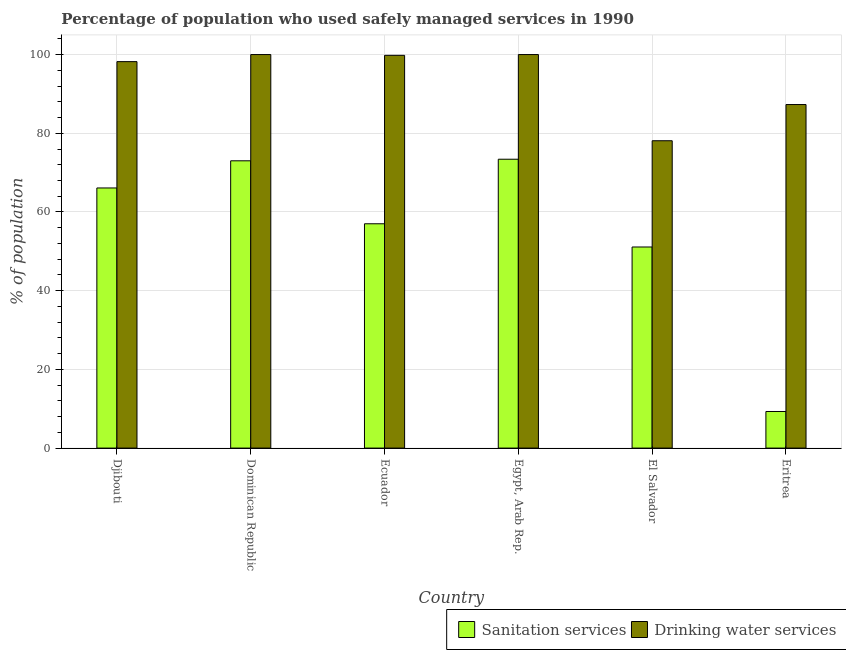How many different coloured bars are there?
Offer a terse response. 2. Are the number of bars per tick equal to the number of legend labels?
Your response must be concise. Yes. How many bars are there on the 3rd tick from the right?
Give a very brief answer. 2. What is the label of the 3rd group of bars from the left?
Your answer should be very brief. Ecuador. In how many cases, is the number of bars for a given country not equal to the number of legend labels?
Provide a succinct answer. 0. What is the percentage of population who used drinking water services in Ecuador?
Your answer should be very brief. 99.8. Across all countries, what is the maximum percentage of population who used sanitation services?
Provide a short and direct response. 73.4. Across all countries, what is the minimum percentage of population who used drinking water services?
Provide a succinct answer. 78.1. In which country was the percentage of population who used sanitation services maximum?
Your answer should be compact. Egypt, Arab Rep. In which country was the percentage of population who used drinking water services minimum?
Ensure brevity in your answer.  El Salvador. What is the total percentage of population who used drinking water services in the graph?
Give a very brief answer. 563.4. What is the difference between the percentage of population who used drinking water services in Djibouti and that in Eritrea?
Your response must be concise. 10.9. What is the difference between the percentage of population who used drinking water services in Ecuador and the percentage of population who used sanitation services in Egypt, Arab Rep.?
Ensure brevity in your answer.  26.4. What is the average percentage of population who used drinking water services per country?
Your answer should be very brief. 93.9. What is the difference between the percentage of population who used sanitation services and percentage of population who used drinking water services in Dominican Republic?
Make the answer very short. -27. What is the ratio of the percentage of population who used sanitation services in Dominican Republic to that in El Salvador?
Provide a succinct answer. 1.43. Is the percentage of population who used sanitation services in Ecuador less than that in Eritrea?
Provide a short and direct response. No. Is the difference between the percentage of population who used sanitation services in Ecuador and Egypt, Arab Rep. greater than the difference between the percentage of population who used drinking water services in Ecuador and Egypt, Arab Rep.?
Make the answer very short. No. What is the difference between the highest and the second highest percentage of population who used sanitation services?
Your answer should be compact. 0.4. What is the difference between the highest and the lowest percentage of population who used drinking water services?
Keep it short and to the point. 21.9. Is the sum of the percentage of population who used sanitation services in Dominican Republic and Eritrea greater than the maximum percentage of population who used drinking water services across all countries?
Keep it short and to the point. No. What does the 1st bar from the left in Djibouti represents?
Your answer should be very brief. Sanitation services. What does the 2nd bar from the right in Egypt, Arab Rep. represents?
Ensure brevity in your answer.  Sanitation services. Are all the bars in the graph horizontal?
Your answer should be compact. No. How many countries are there in the graph?
Your answer should be compact. 6. Does the graph contain any zero values?
Provide a short and direct response. No. How many legend labels are there?
Provide a short and direct response. 2. How are the legend labels stacked?
Keep it short and to the point. Horizontal. What is the title of the graph?
Provide a short and direct response. Percentage of population who used safely managed services in 1990. What is the label or title of the X-axis?
Offer a very short reply. Country. What is the label or title of the Y-axis?
Make the answer very short. % of population. What is the % of population in Sanitation services in Djibouti?
Your answer should be very brief. 66.1. What is the % of population in Drinking water services in Djibouti?
Offer a very short reply. 98.2. What is the % of population of Sanitation services in Dominican Republic?
Keep it short and to the point. 73. What is the % of population of Drinking water services in Dominican Republic?
Provide a succinct answer. 100. What is the % of population of Drinking water services in Ecuador?
Provide a short and direct response. 99.8. What is the % of population in Sanitation services in Egypt, Arab Rep.?
Ensure brevity in your answer.  73.4. What is the % of population in Drinking water services in Egypt, Arab Rep.?
Offer a terse response. 100. What is the % of population in Sanitation services in El Salvador?
Offer a very short reply. 51.1. What is the % of population of Drinking water services in El Salvador?
Your answer should be compact. 78.1. What is the % of population of Sanitation services in Eritrea?
Your answer should be very brief. 9.3. What is the % of population in Drinking water services in Eritrea?
Give a very brief answer. 87.3. Across all countries, what is the maximum % of population of Sanitation services?
Ensure brevity in your answer.  73.4. Across all countries, what is the minimum % of population in Sanitation services?
Your response must be concise. 9.3. Across all countries, what is the minimum % of population of Drinking water services?
Provide a short and direct response. 78.1. What is the total % of population in Sanitation services in the graph?
Your answer should be very brief. 329.9. What is the total % of population of Drinking water services in the graph?
Provide a short and direct response. 563.4. What is the difference between the % of population in Sanitation services in Djibouti and that in Dominican Republic?
Ensure brevity in your answer.  -6.9. What is the difference between the % of population in Sanitation services in Djibouti and that in Ecuador?
Give a very brief answer. 9.1. What is the difference between the % of population of Sanitation services in Djibouti and that in Egypt, Arab Rep.?
Your response must be concise. -7.3. What is the difference between the % of population in Sanitation services in Djibouti and that in El Salvador?
Give a very brief answer. 15. What is the difference between the % of population of Drinking water services in Djibouti and that in El Salvador?
Offer a very short reply. 20.1. What is the difference between the % of population in Sanitation services in Djibouti and that in Eritrea?
Keep it short and to the point. 56.8. What is the difference between the % of population of Drinking water services in Dominican Republic and that in Ecuador?
Your answer should be compact. 0.2. What is the difference between the % of population of Drinking water services in Dominican Republic and that in Egypt, Arab Rep.?
Offer a terse response. 0. What is the difference between the % of population of Sanitation services in Dominican Republic and that in El Salvador?
Your answer should be very brief. 21.9. What is the difference between the % of population in Drinking water services in Dominican Republic and that in El Salvador?
Ensure brevity in your answer.  21.9. What is the difference between the % of population in Sanitation services in Dominican Republic and that in Eritrea?
Offer a terse response. 63.7. What is the difference between the % of population in Sanitation services in Ecuador and that in Egypt, Arab Rep.?
Keep it short and to the point. -16.4. What is the difference between the % of population of Sanitation services in Ecuador and that in El Salvador?
Give a very brief answer. 5.9. What is the difference between the % of population of Drinking water services in Ecuador and that in El Salvador?
Give a very brief answer. 21.7. What is the difference between the % of population in Sanitation services in Ecuador and that in Eritrea?
Your answer should be compact. 47.7. What is the difference between the % of population in Sanitation services in Egypt, Arab Rep. and that in El Salvador?
Keep it short and to the point. 22.3. What is the difference between the % of population of Drinking water services in Egypt, Arab Rep. and that in El Salvador?
Offer a terse response. 21.9. What is the difference between the % of population of Sanitation services in Egypt, Arab Rep. and that in Eritrea?
Ensure brevity in your answer.  64.1. What is the difference between the % of population of Drinking water services in Egypt, Arab Rep. and that in Eritrea?
Make the answer very short. 12.7. What is the difference between the % of population of Sanitation services in El Salvador and that in Eritrea?
Your answer should be very brief. 41.8. What is the difference between the % of population of Sanitation services in Djibouti and the % of population of Drinking water services in Dominican Republic?
Your answer should be very brief. -33.9. What is the difference between the % of population of Sanitation services in Djibouti and the % of population of Drinking water services in Ecuador?
Offer a very short reply. -33.7. What is the difference between the % of population in Sanitation services in Djibouti and the % of population in Drinking water services in Egypt, Arab Rep.?
Give a very brief answer. -33.9. What is the difference between the % of population in Sanitation services in Djibouti and the % of population in Drinking water services in Eritrea?
Your answer should be compact. -21.2. What is the difference between the % of population in Sanitation services in Dominican Republic and the % of population in Drinking water services in Ecuador?
Your answer should be compact. -26.8. What is the difference between the % of population in Sanitation services in Dominican Republic and the % of population in Drinking water services in Eritrea?
Make the answer very short. -14.3. What is the difference between the % of population of Sanitation services in Ecuador and the % of population of Drinking water services in Egypt, Arab Rep.?
Provide a short and direct response. -43. What is the difference between the % of population of Sanitation services in Ecuador and the % of population of Drinking water services in El Salvador?
Offer a very short reply. -21.1. What is the difference between the % of population in Sanitation services in Ecuador and the % of population in Drinking water services in Eritrea?
Offer a very short reply. -30.3. What is the difference between the % of population of Sanitation services in Egypt, Arab Rep. and the % of population of Drinking water services in El Salvador?
Make the answer very short. -4.7. What is the difference between the % of population in Sanitation services in Egypt, Arab Rep. and the % of population in Drinking water services in Eritrea?
Your answer should be very brief. -13.9. What is the difference between the % of population in Sanitation services in El Salvador and the % of population in Drinking water services in Eritrea?
Offer a terse response. -36.2. What is the average % of population of Sanitation services per country?
Your response must be concise. 54.98. What is the average % of population of Drinking water services per country?
Offer a very short reply. 93.9. What is the difference between the % of population in Sanitation services and % of population in Drinking water services in Djibouti?
Offer a terse response. -32.1. What is the difference between the % of population in Sanitation services and % of population in Drinking water services in Dominican Republic?
Ensure brevity in your answer.  -27. What is the difference between the % of population of Sanitation services and % of population of Drinking water services in Ecuador?
Your answer should be compact. -42.8. What is the difference between the % of population of Sanitation services and % of population of Drinking water services in Egypt, Arab Rep.?
Provide a succinct answer. -26.6. What is the difference between the % of population in Sanitation services and % of population in Drinking water services in El Salvador?
Make the answer very short. -27. What is the difference between the % of population in Sanitation services and % of population in Drinking water services in Eritrea?
Make the answer very short. -78. What is the ratio of the % of population of Sanitation services in Djibouti to that in Dominican Republic?
Your answer should be very brief. 0.91. What is the ratio of the % of population of Sanitation services in Djibouti to that in Ecuador?
Ensure brevity in your answer.  1.16. What is the ratio of the % of population of Drinking water services in Djibouti to that in Ecuador?
Your answer should be very brief. 0.98. What is the ratio of the % of population in Sanitation services in Djibouti to that in Egypt, Arab Rep.?
Your answer should be compact. 0.9. What is the ratio of the % of population in Drinking water services in Djibouti to that in Egypt, Arab Rep.?
Ensure brevity in your answer.  0.98. What is the ratio of the % of population of Sanitation services in Djibouti to that in El Salvador?
Make the answer very short. 1.29. What is the ratio of the % of population in Drinking water services in Djibouti to that in El Salvador?
Provide a short and direct response. 1.26. What is the ratio of the % of population in Sanitation services in Djibouti to that in Eritrea?
Your response must be concise. 7.11. What is the ratio of the % of population in Drinking water services in Djibouti to that in Eritrea?
Your answer should be compact. 1.12. What is the ratio of the % of population in Sanitation services in Dominican Republic to that in Ecuador?
Provide a succinct answer. 1.28. What is the ratio of the % of population in Sanitation services in Dominican Republic to that in El Salvador?
Your answer should be very brief. 1.43. What is the ratio of the % of population in Drinking water services in Dominican Republic to that in El Salvador?
Provide a succinct answer. 1.28. What is the ratio of the % of population of Sanitation services in Dominican Republic to that in Eritrea?
Ensure brevity in your answer.  7.85. What is the ratio of the % of population of Drinking water services in Dominican Republic to that in Eritrea?
Make the answer very short. 1.15. What is the ratio of the % of population in Sanitation services in Ecuador to that in Egypt, Arab Rep.?
Offer a terse response. 0.78. What is the ratio of the % of population in Drinking water services in Ecuador to that in Egypt, Arab Rep.?
Offer a terse response. 1. What is the ratio of the % of population of Sanitation services in Ecuador to that in El Salvador?
Provide a succinct answer. 1.12. What is the ratio of the % of population in Drinking water services in Ecuador to that in El Salvador?
Your answer should be very brief. 1.28. What is the ratio of the % of population of Sanitation services in Ecuador to that in Eritrea?
Give a very brief answer. 6.13. What is the ratio of the % of population of Drinking water services in Ecuador to that in Eritrea?
Provide a succinct answer. 1.14. What is the ratio of the % of population of Sanitation services in Egypt, Arab Rep. to that in El Salvador?
Make the answer very short. 1.44. What is the ratio of the % of population in Drinking water services in Egypt, Arab Rep. to that in El Salvador?
Give a very brief answer. 1.28. What is the ratio of the % of population in Sanitation services in Egypt, Arab Rep. to that in Eritrea?
Give a very brief answer. 7.89. What is the ratio of the % of population of Drinking water services in Egypt, Arab Rep. to that in Eritrea?
Offer a terse response. 1.15. What is the ratio of the % of population in Sanitation services in El Salvador to that in Eritrea?
Offer a terse response. 5.49. What is the ratio of the % of population in Drinking water services in El Salvador to that in Eritrea?
Your answer should be very brief. 0.89. What is the difference between the highest and the second highest % of population of Sanitation services?
Ensure brevity in your answer.  0.4. What is the difference between the highest and the second highest % of population in Drinking water services?
Provide a succinct answer. 0. What is the difference between the highest and the lowest % of population in Sanitation services?
Provide a succinct answer. 64.1. What is the difference between the highest and the lowest % of population of Drinking water services?
Offer a terse response. 21.9. 